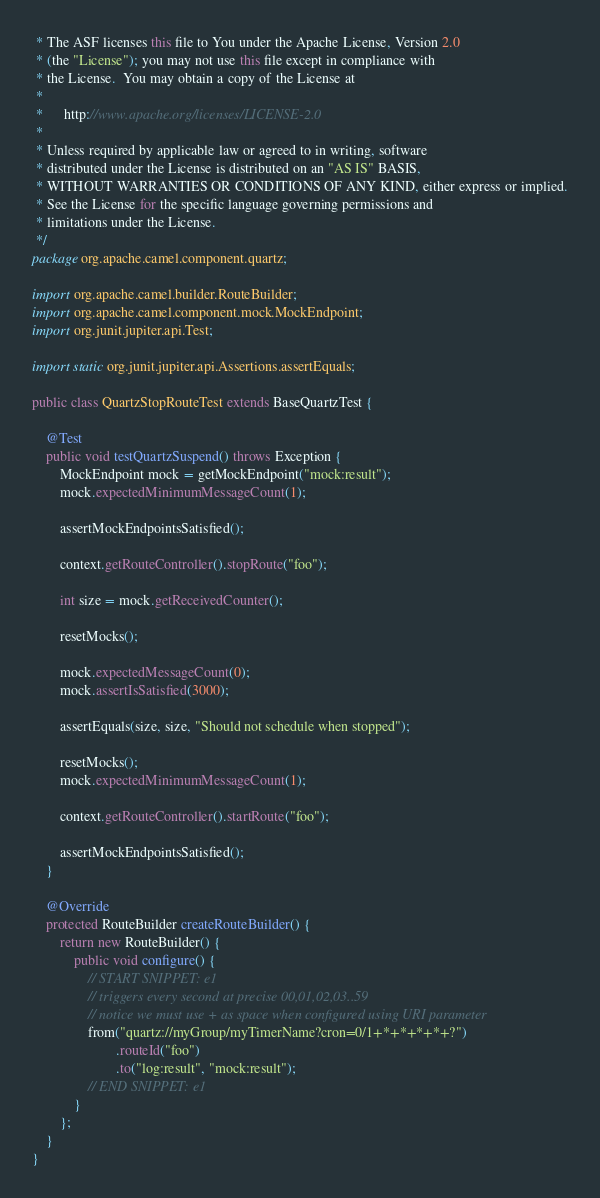<code> <loc_0><loc_0><loc_500><loc_500><_Java_> * The ASF licenses this file to You under the Apache License, Version 2.0
 * (the "License"); you may not use this file except in compliance with
 * the License.  You may obtain a copy of the License at
 *
 *      http://www.apache.org/licenses/LICENSE-2.0
 *
 * Unless required by applicable law or agreed to in writing, software
 * distributed under the License is distributed on an "AS IS" BASIS,
 * WITHOUT WARRANTIES OR CONDITIONS OF ANY KIND, either express or implied.
 * See the License for the specific language governing permissions and
 * limitations under the License.
 */
package org.apache.camel.component.quartz;

import org.apache.camel.builder.RouteBuilder;
import org.apache.camel.component.mock.MockEndpoint;
import org.junit.jupiter.api.Test;

import static org.junit.jupiter.api.Assertions.assertEquals;

public class QuartzStopRouteTest extends BaseQuartzTest {

    @Test
    public void testQuartzSuspend() throws Exception {
        MockEndpoint mock = getMockEndpoint("mock:result");
        mock.expectedMinimumMessageCount(1);

        assertMockEndpointsSatisfied();

        context.getRouteController().stopRoute("foo");

        int size = mock.getReceivedCounter();

        resetMocks();

        mock.expectedMessageCount(0);
        mock.assertIsSatisfied(3000);

        assertEquals(size, size, "Should not schedule when stopped");

        resetMocks();
        mock.expectedMinimumMessageCount(1);

        context.getRouteController().startRoute("foo");

        assertMockEndpointsSatisfied();
    }

    @Override
    protected RouteBuilder createRouteBuilder() {
        return new RouteBuilder() {
            public void configure() {
                // START SNIPPET: e1
                // triggers every second at precise 00,01,02,03..59
                // notice we must use + as space when configured using URI parameter
                from("quartz://myGroup/myTimerName?cron=0/1+*+*+*+*+?")
                        .routeId("foo")
                        .to("log:result", "mock:result");
                // END SNIPPET: e1
            }
        };
    }
}
</code> 